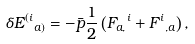Convert formula to latex. <formula><loc_0><loc_0><loc_500><loc_500>\delta { E ^ { ( i } } _ { a ) } = - \bar { p } \frac { 1 } { 2 } \left ( { F _ { a , } } ^ { i } + { F ^ { i } } _ { , a } \right ) ,</formula> 